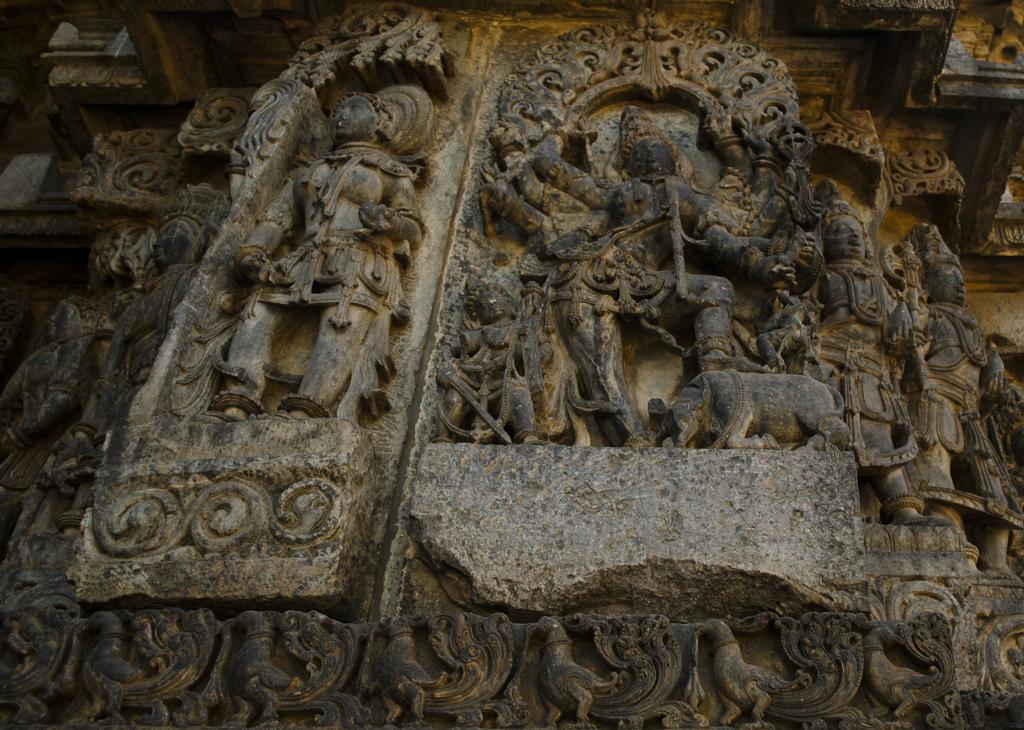In one or two sentences, can you explain what this image depicts? In this image I can see the sculptures and carvings on a rock. 